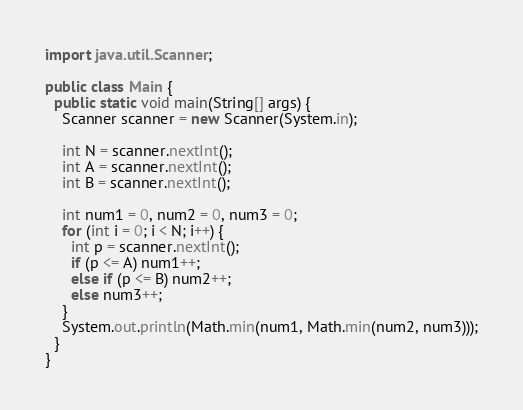<code> <loc_0><loc_0><loc_500><loc_500><_Java_>import java.util.Scanner;

public class Main {
  public static void main(String[] args) {
    Scanner scanner = new Scanner(System.in);

    int N = scanner.nextInt();
    int A = scanner.nextInt();
    int B = scanner.nextInt();

    int num1 = 0, num2 = 0, num3 = 0;
    for (int i = 0; i < N; i++) {
      int p = scanner.nextInt();
      if (p <= A) num1++;
      else if (p <= B) num2++;
      else num3++;
    }
    System.out.println(Math.min(num1, Math.min(num2, num3)));
  }
}
</code> 